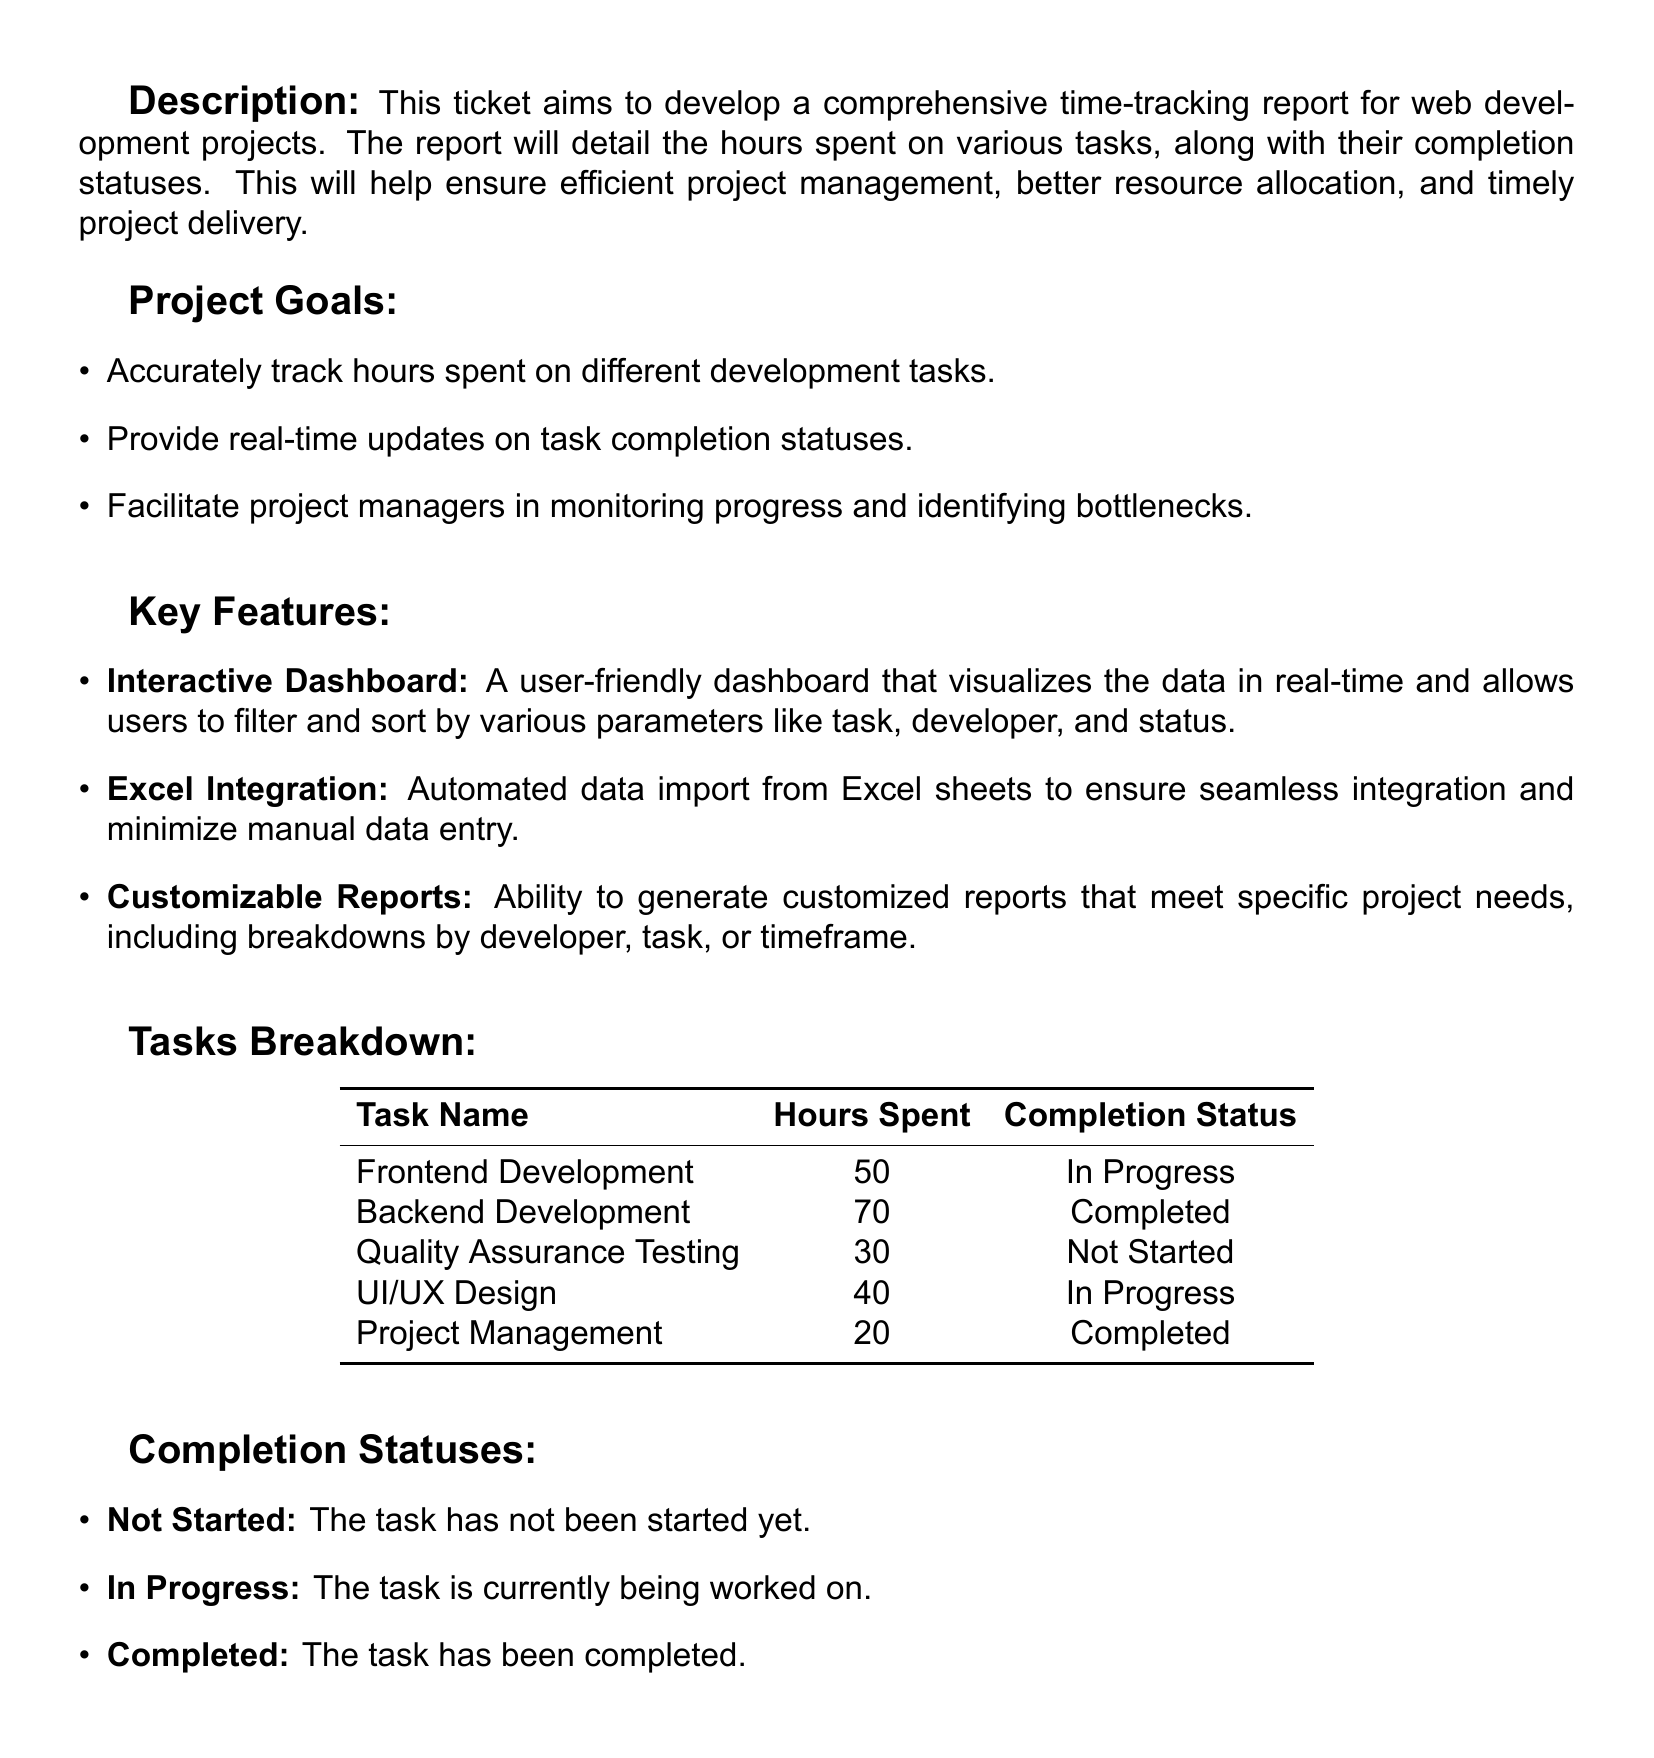What is the title of the report? The title of the report is displayed prominently at the top of the document.
Answer: Time-Tracking Report for Web Development Projects How many hours were spent on Backend Development? The document provides specific hours spent for each task in the Tasks Breakdown section.
Answer: 70 What is the completion status of Quality Assurance Testing? The completion status is listed alongside each task in the Tasks Breakdown.
Answer: Not Started Which task has the least hours spent? The hours spent for each task can be compared to determine which one has the least.
Answer: Project Management What is one goal of the project? The document lists several goals in the Project Goals section.
Answer: Accurately track hours spent on different development tasks How many tasks are currently in progress? The completion statuses indicate how many tasks are not marked as completed or not started.
Answer: 2 What feature allows for real-time updates? The Key Features section describes features of the report, including the interactive dashboard.
Answer: Interactive Dashboard What is the total number of hours spent across all tasks? The hours for each task must be added together to calculate the total.
Answer: 210 Which task had the highest hours spent? The Tasks Breakdown provides a comparison of hours spent for each task.
Answer: Backend Development 